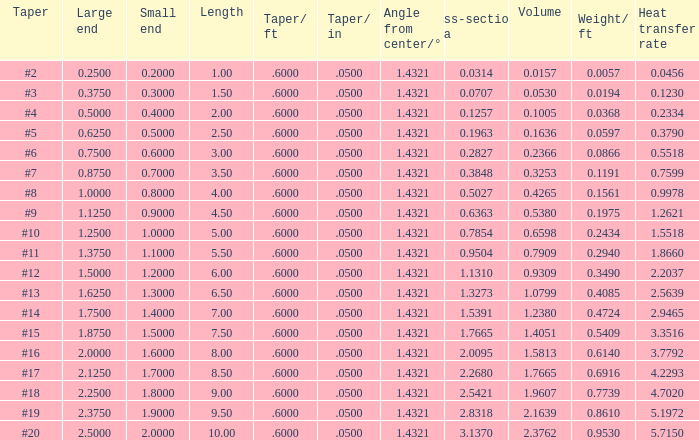Which Length has a Taper of #15, and a Large end larger than 1.875? None. 